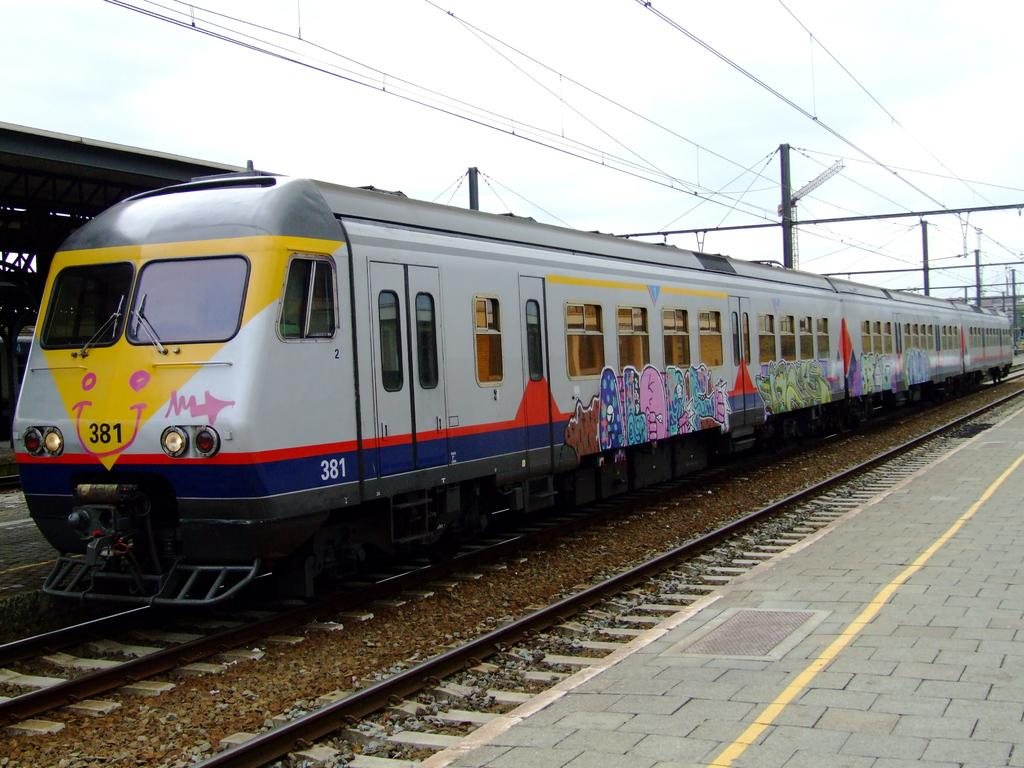What is the main subject of the image? The main subject of the image is a train. Where is the train located in the image? The train is on the left side of the image. What is present on the right side of the image? There is a platform on the right side of the image. What can be seen above the train and platform in the image? The sky is visible above the train and platform. What is the value of the screw holding the train together in the image? There is no screw holding the train together in the image, as trains are typically held together by various mechanical components and not a single screw. 